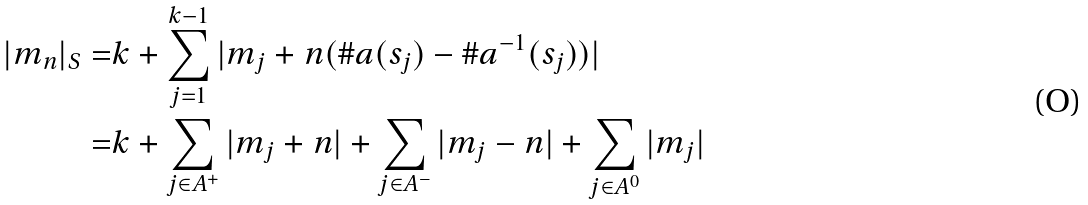Convert formula to latex. <formula><loc_0><loc_0><loc_500><loc_500>| m _ { n } | _ { S } = & k + \sum _ { j = 1 } ^ { k - 1 } | m _ { j } + n ( \# a ( s _ { j } ) - \# a ^ { - 1 } ( s _ { j } ) ) | \\ = & k + \sum _ { j \in A ^ { + } } | m _ { j } + n | + \sum _ { j \in A ^ { - } } | m _ { j } - n | + \sum _ { j \in A ^ { 0 } } | m _ { j } |</formula> 